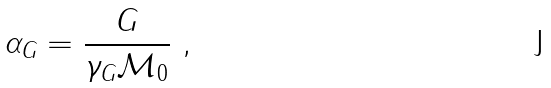<formula> <loc_0><loc_0><loc_500><loc_500>\alpha _ { G } = \frac { G } { \gamma _ { G } \mathcal { M } _ { 0 } } \ ,</formula> 